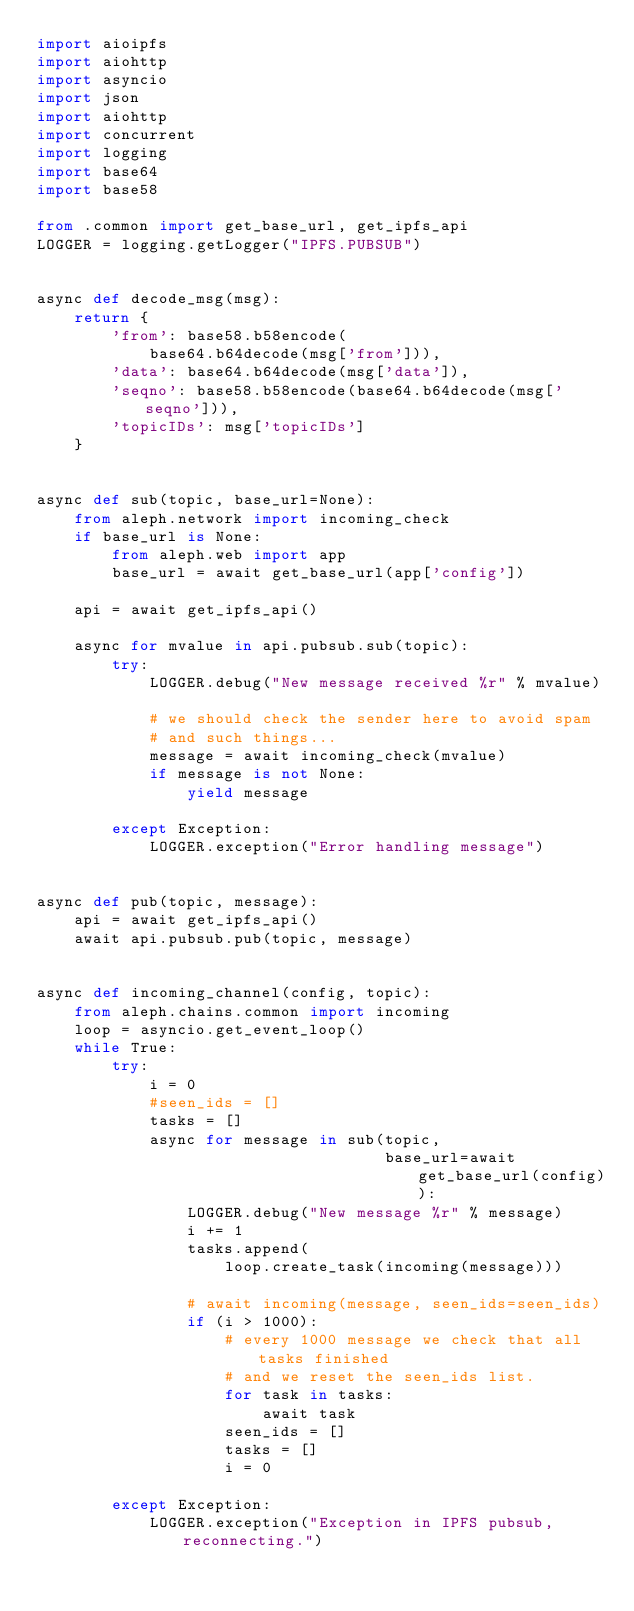Convert code to text. <code><loc_0><loc_0><loc_500><loc_500><_Python_>import aioipfs
import aiohttp
import asyncio
import json
import aiohttp
import concurrent
import logging
import base64
import base58

from .common import get_base_url, get_ipfs_api
LOGGER = logging.getLogger("IPFS.PUBSUB")


async def decode_msg(msg):
    return {
        'from': base58.b58encode(
            base64.b64decode(msg['from'])),
        'data': base64.b64decode(msg['data']),
        'seqno': base58.b58encode(base64.b64decode(msg['seqno'])),
        'topicIDs': msg['topicIDs']
    }


async def sub(topic, base_url=None):
    from aleph.network import incoming_check
    if base_url is None:
        from aleph.web import app
        base_url = await get_base_url(app['config'])
        
    api = await get_ipfs_api()
    
    async for mvalue in api.pubsub.sub(topic):
        try:
            LOGGER.debug("New message received %r" % mvalue)

            # we should check the sender here to avoid spam
            # and such things...
            message = await incoming_check(mvalue)
            if message is not None:
                yield message

        except Exception:
            LOGGER.exception("Error handling message")


async def pub(topic, message):
    api = await get_ipfs_api()
    await api.pubsub.pub(topic, message)


async def incoming_channel(config, topic):
    from aleph.chains.common import incoming
    loop = asyncio.get_event_loop()
    while True:
        try:
            i = 0
            #seen_ids = []
            tasks = []
            async for message in sub(topic,
                                     base_url=await get_base_url(config)):
                LOGGER.debug("New message %r" % message)
                i += 1
                tasks.append(
                    loop.create_task(incoming(message)))

                # await incoming(message, seen_ids=seen_ids)
                if (i > 1000):
                    # every 1000 message we check that all tasks finished
                    # and we reset the seen_ids list.
                    for task in tasks:
                        await task
                    seen_ids = []
                    tasks = []
                    i = 0

        except Exception:
            LOGGER.exception("Exception in IPFS pubsub, reconnecting.")</code> 